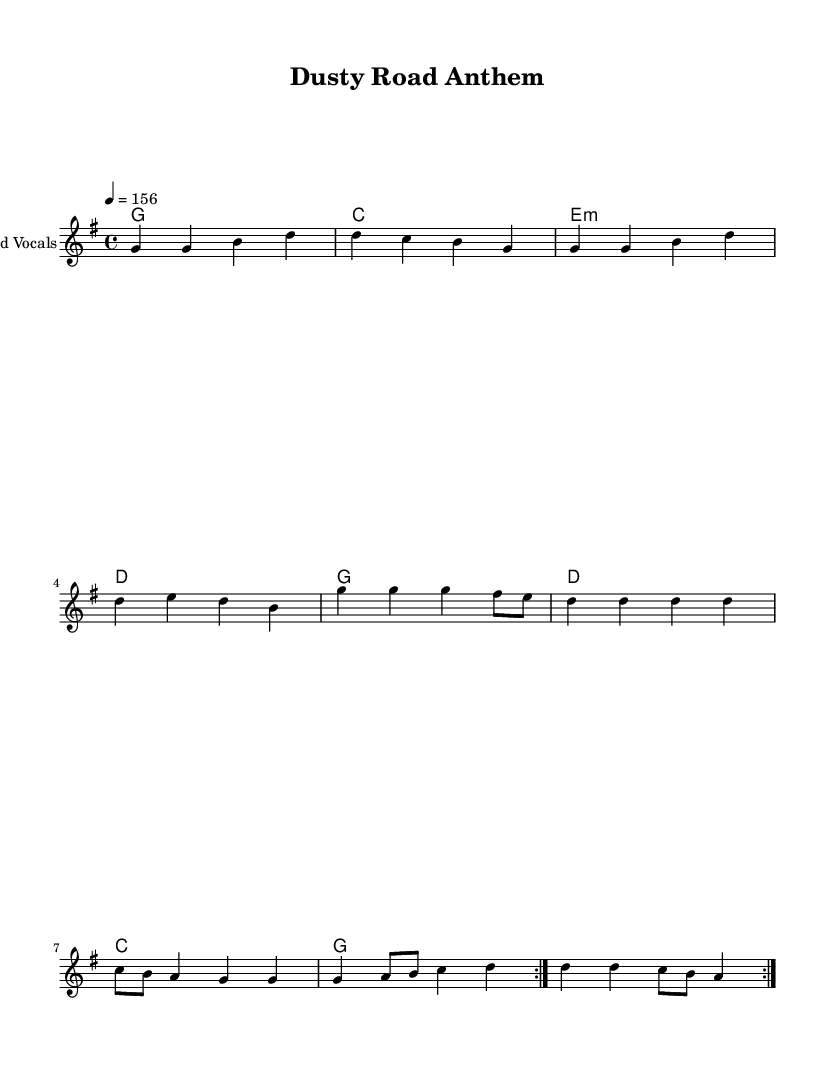What is the key signature of this music? The key signature is G major, which has one sharp (F#). This can be identified by the key signature indicated at the beginning of the score.
Answer: G major What is the time signature of this music? The time signature is 4/4, which indicates four beats per measure. This is shown at the beginning of the score next to the key signature.
Answer: 4/4 What is the tempo of this piece? The tempo is specified as 156 beats per minute. This is shown in the tempo markings included in the score.
Answer: 156 How many measures are repeated in the melody? The melody section includes two measures repeated. The repeat symbols (volta) indicate that the first set of measures should be played twice.
Answer: 2 What are the main chords used in this piece? The main chords used are G, C, E minor, and D. These chords are indicated in the chord names section of the score aligned with the melody.
Answer: G, C, E minor, D What is the predominant vocal line dynamic indicated in this score? The vocal line does not specify dynamics in the provided snippet, but typically in country rock, a dynamic vocal processing might emphasize bold tonal qualities. Checking for any markings can provide specifics.
Answer: Not specified How does the structure of the song reflect up-tempo characteristics typical of country rock? The structure includes fast-paced rhythm (160 BPM and 4/4 time) with repeated melodies which are characteristic of the upbeat and energetic feel often found in country rock anthems. This reinforces engagement and a lively performance style.
Answer: Up-tempo and energetic 